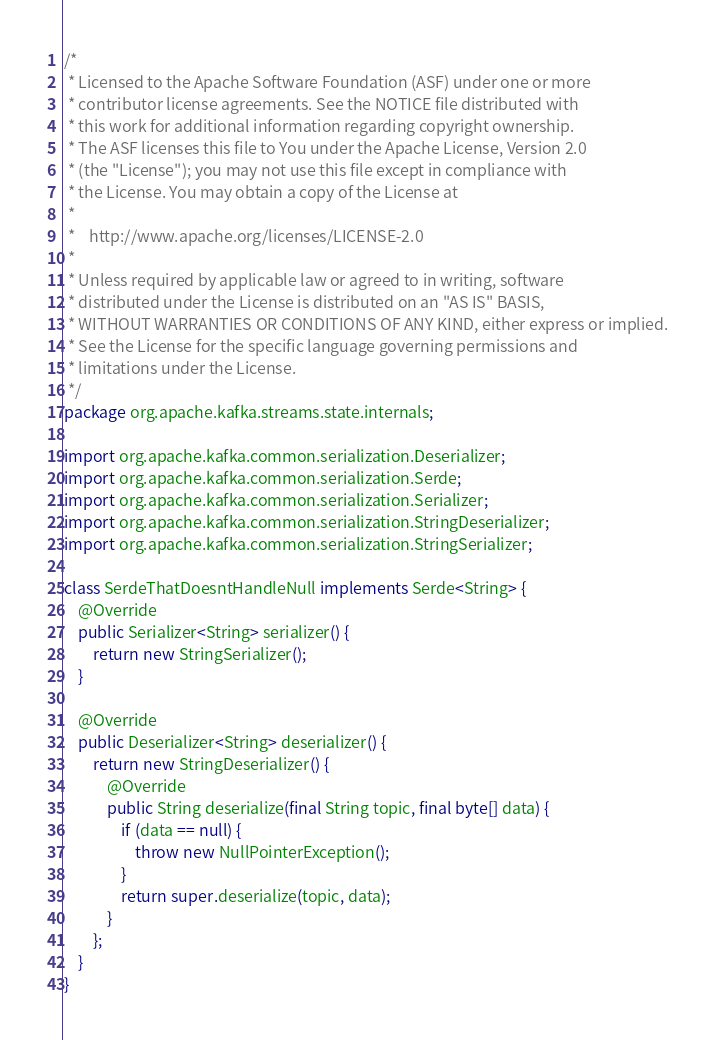Convert code to text. <code><loc_0><loc_0><loc_500><loc_500><_Java_>/*
 * Licensed to the Apache Software Foundation (ASF) under one or more
 * contributor license agreements. See the NOTICE file distributed with
 * this work for additional information regarding copyright ownership.
 * The ASF licenses this file to You under the Apache License, Version 2.0
 * (the "License"); you may not use this file except in compliance with
 * the License. You may obtain a copy of the License at
 *
 *    http://www.apache.org/licenses/LICENSE-2.0
 *
 * Unless required by applicable law or agreed to in writing, software
 * distributed under the License is distributed on an "AS IS" BASIS,
 * WITHOUT WARRANTIES OR CONDITIONS OF ANY KIND, either express or implied.
 * See the License for the specific language governing permissions and
 * limitations under the License.
 */
package org.apache.kafka.streams.state.internals;

import org.apache.kafka.common.serialization.Deserializer;
import org.apache.kafka.common.serialization.Serde;
import org.apache.kafka.common.serialization.Serializer;
import org.apache.kafka.common.serialization.StringDeserializer;
import org.apache.kafka.common.serialization.StringSerializer;

class SerdeThatDoesntHandleNull implements Serde<String> {
    @Override
    public Serializer<String> serializer() {
        return new StringSerializer();
    }

    @Override
    public Deserializer<String> deserializer() {
        return new StringDeserializer() {
            @Override
            public String deserialize(final String topic, final byte[] data) {
                if (data == null) {
                    throw new NullPointerException();
                }
                return super.deserialize(topic, data);
            }
        };
    }
}
</code> 